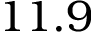Convert formula to latex. <formula><loc_0><loc_0><loc_500><loc_500>1 1 . 9</formula> 